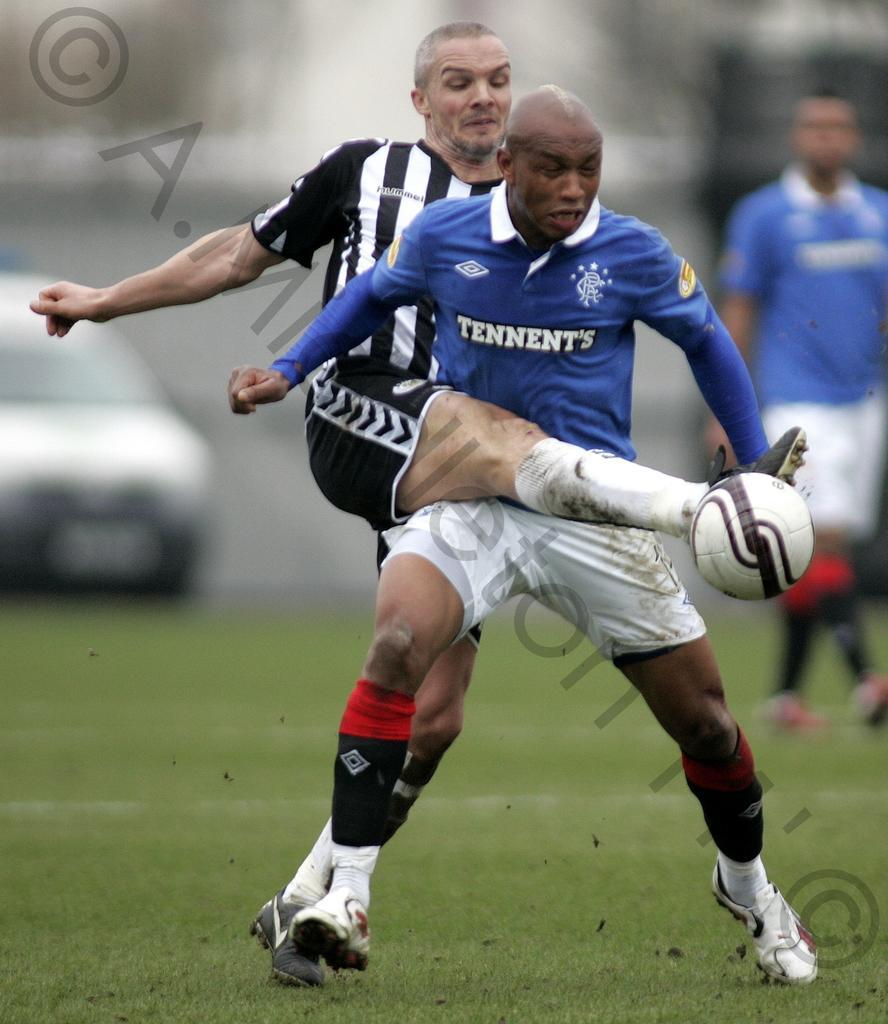In one or two sentences, can you explain what this image depicts? Here we can see a person running, and another person hitting the ball, and at back the car is on the ground. 